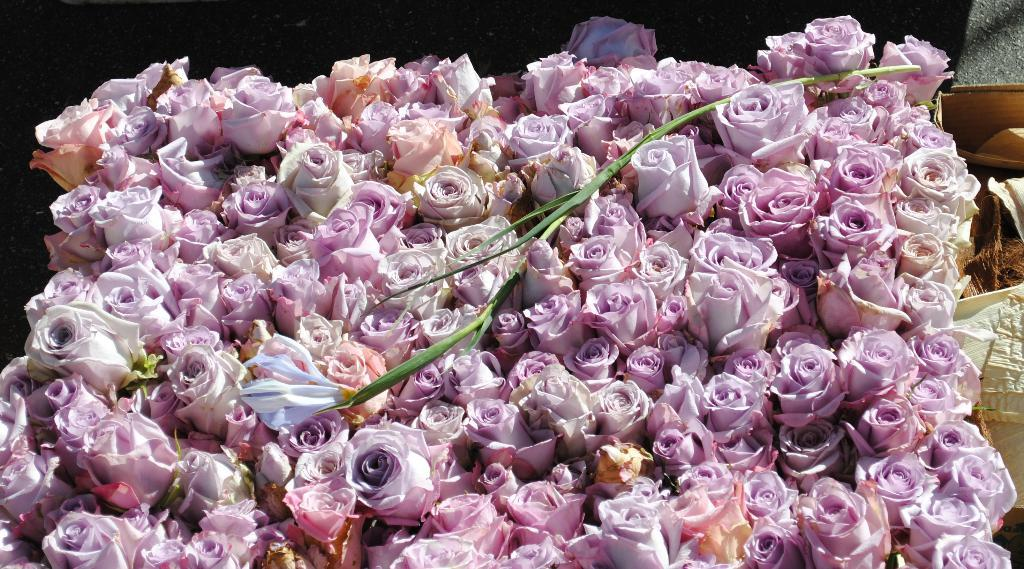What type of flowers can be seen in the image? There are pink color flowers in the image. What type of crime is being committed in the image? There is no crime present in the image; it features pink color flowers. What kind of band is playing in the background of the image? There is no band present in the image; it features pink color flowers. 